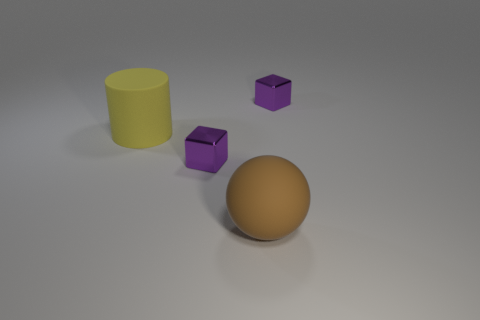There is a big yellow object left of the tiny shiny object in front of the big yellow matte object; what is its shape? cylinder 